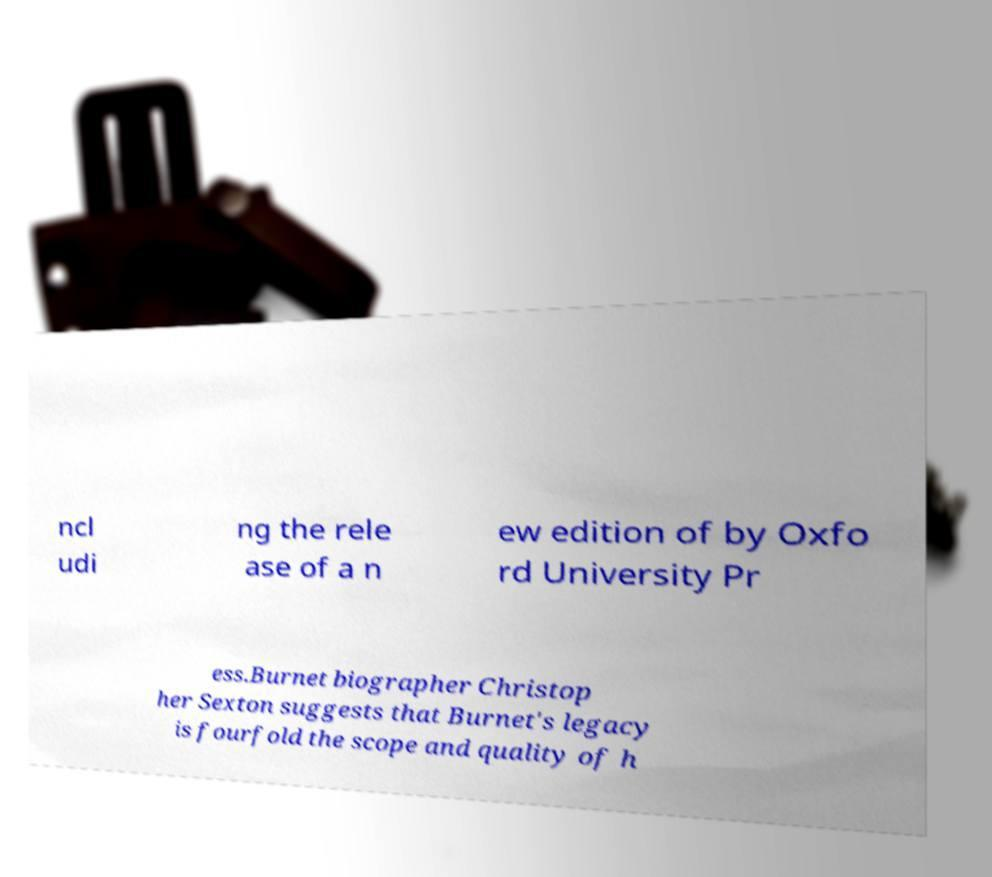Can you accurately transcribe the text from the provided image for me? ncl udi ng the rele ase of a n ew edition of by Oxfo rd University Pr ess.Burnet biographer Christop her Sexton suggests that Burnet's legacy is fourfold the scope and quality of h 